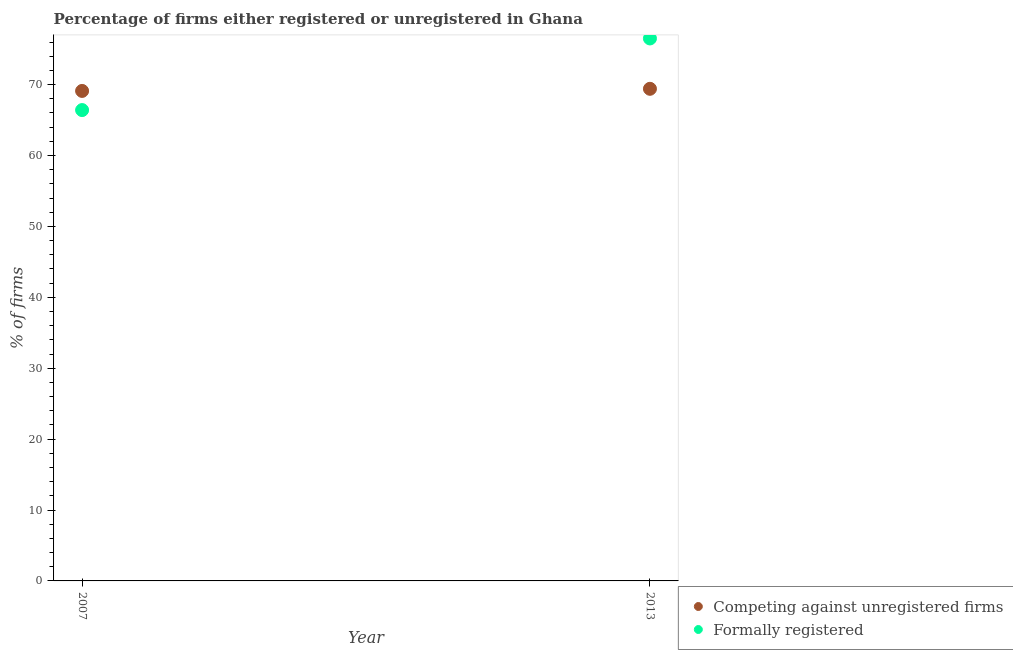How many different coloured dotlines are there?
Your answer should be compact. 2. What is the percentage of registered firms in 2007?
Offer a very short reply. 69.1. Across all years, what is the maximum percentage of registered firms?
Offer a terse response. 69.4. Across all years, what is the minimum percentage of formally registered firms?
Provide a short and direct response. 66.4. In which year was the percentage of registered firms maximum?
Your answer should be compact. 2013. What is the total percentage of formally registered firms in the graph?
Make the answer very short. 142.9. What is the difference between the percentage of registered firms in 2007 and that in 2013?
Provide a succinct answer. -0.3. What is the difference between the percentage of registered firms in 2007 and the percentage of formally registered firms in 2013?
Make the answer very short. -7.4. What is the average percentage of registered firms per year?
Your response must be concise. 69.25. In the year 2013, what is the difference between the percentage of formally registered firms and percentage of registered firms?
Your answer should be compact. 7.1. In how many years, is the percentage of formally registered firms greater than 2 %?
Your response must be concise. 2. What is the ratio of the percentage of formally registered firms in 2007 to that in 2013?
Your answer should be very brief. 0.87. Is the percentage of registered firms in 2007 less than that in 2013?
Provide a short and direct response. Yes. Does the percentage of formally registered firms monotonically increase over the years?
Your response must be concise. Yes. Is the percentage of formally registered firms strictly less than the percentage of registered firms over the years?
Make the answer very short. No. How many dotlines are there?
Make the answer very short. 2. How many years are there in the graph?
Give a very brief answer. 2. What is the difference between two consecutive major ticks on the Y-axis?
Make the answer very short. 10. How are the legend labels stacked?
Your response must be concise. Vertical. What is the title of the graph?
Make the answer very short. Percentage of firms either registered or unregistered in Ghana. What is the label or title of the X-axis?
Give a very brief answer. Year. What is the label or title of the Y-axis?
Give a very brief answer. % of firms. What is the % of firms in Competing against unregistered firms in 2007?
Your answer should be compact. 69.1. What is the % of firms of Formally registered in 2007?
Provide a short and direct response. 66.4. What is the % of firms in Competing against unregistered firms in 2013?
Give a very brief answer. 69.4. What is the % of firms of Formally registered in 2013?
Keep it short and to the point. 76.5. Across all years, what is the maximum % of firms of Competing against unregistered firms?
Your answer should be very brief. 69.4. Across all years, what is the maximum % of firms in Formally registered?
Make the answer very short. 76.5. Across all years, what is the minimum % of firms in Competing against unregistered firms?
Keep it short and to the point. 69.1. Across all years, what is the minimum % of firms of Formally registered?
Provide a succinct answer. 66.4. What is the total % of firms in Competing against unregistered firms in the graph?
Ensure brevity in your answer.  138.5. What is the total % of firms of Formally registered in the graph?
Make the answer very short. 142.9. What is the difference between the % of firms of Competing against unregistered firms in 2007 and that in 2013?
Ensure brevity in your answer.  -0.3. What is the difference between the % of firms of Formally registered in 2007 and that in 2013?
Ensure brevity in your answer.  -10.1. What is the difference between the % of firms of Competing against unregistered firms in 2007 and the % of firms of Formally registered in 2013?
Provide a succinct answer. -7.4. What is the average % of firms in Competing against unregistered firms per year?
Your answer should be compact. 69.25. What is the average % of firms in Formally registered per year?
Ensure brevity in your answer.  71.45. In the year 2007, what is the difference between the % of firms of Competing against unregistered firms and % of firms of Formally registered?
Your response must be concise. 2.7. What is the ratio of the % of firms of Formally registered in 2007 to that in 2013?
Provide a succinct answer. 0.87. What is the difference between the highest and the second highest % of firms in Competing against unregistered firms?
Provide a short and direct response. 0.3. What is the difference between the highest and the lowest % of firms in Formally registered?
Provide a short and direct response. 10.1. 